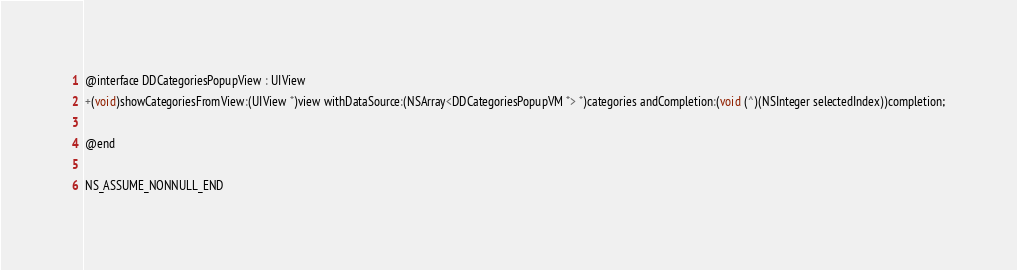<code> <loc_0><loc_0><loc_500><loc_500><_C_>@interface DDCategoriesPopupView : UIView
+(void)showCategoriesFromView:(UIView *)view withDataSource:(NSArray<DDCategoriesPopupVM *> *)categories andCompletion:(void (^)(NSInteger selectedIndex))completion;

@end

NS_ASSUME_NONNULL_END
</code> 